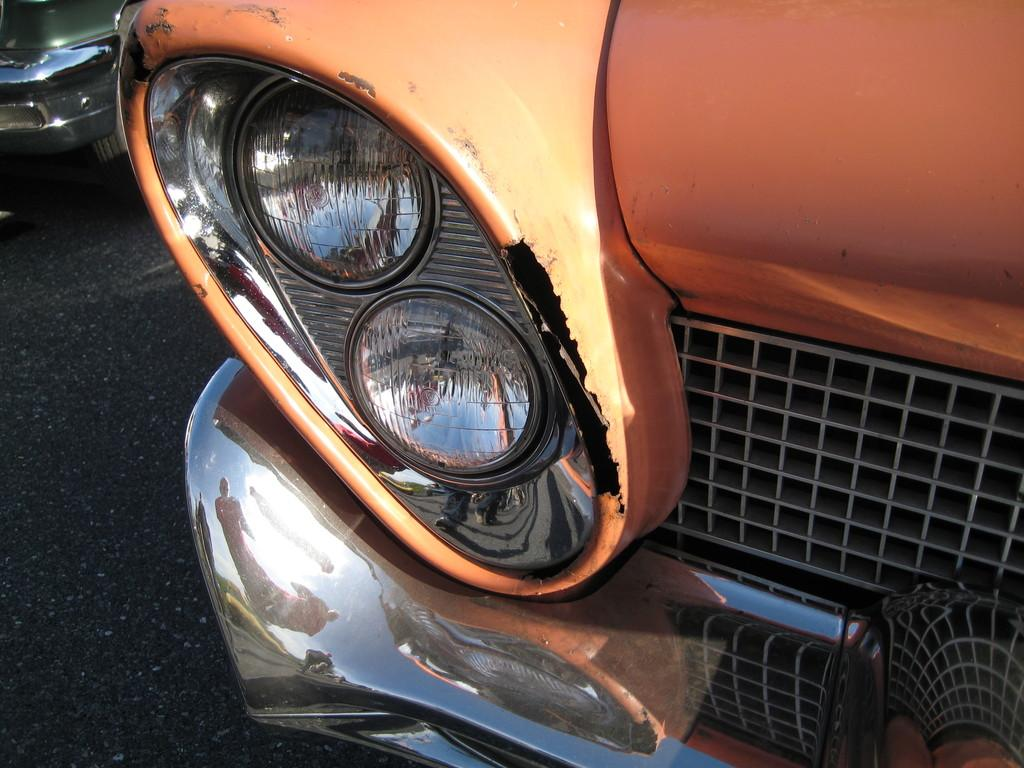What part of a vehicle is shown in the image? The image shows the front side part of a vehicle. What specific feature can be seen on the vehicle? There is a headlight visible on the vehicle. What other components are present on the front of the vehicle? There is a grill and a bumper on the vehicle. Can you describe the background of the image? There is another vehicle in the background of the image. What type of ink is used to write the vehicle's license plate number in the image? There is no visible license plate in the image, and therefore no ink can be observed. 